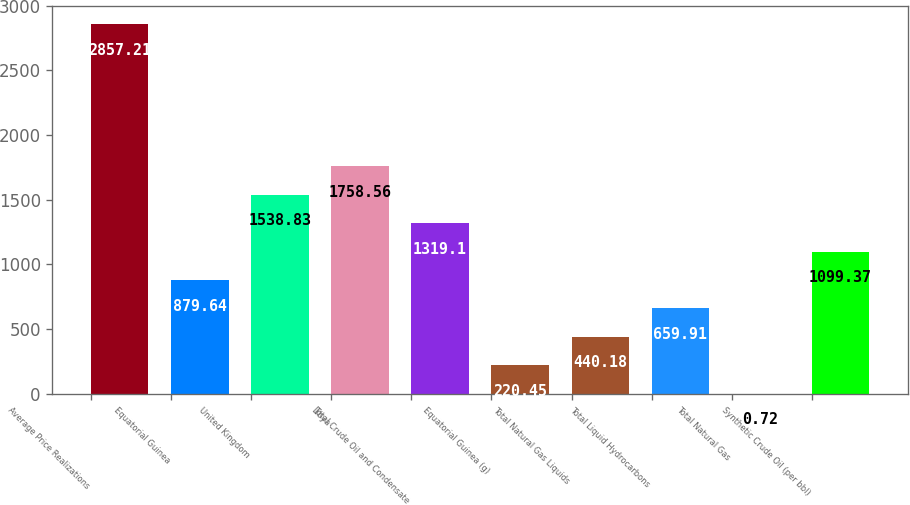Convert chart. <chart><loc_0><loc_0><loc_500><loc_500><bar_chart><fcel>Average Price Realizations<fcel>Equatorial Guinea<fcel>United Kingdom<fcel>Libya<fcel>Total Crude Oil and Condensate<fcel>Equatorial Guinea (g)<fcel>Total Natural Gas Liquids<fcel>Total Liquid Hydrocarbons<fcel>Total Natural Gas<fcel>Synthetic Crude Oil (per bbl)<nl><fcel>2857.21<fcel>879.64<fcel>1538.83<fcel>1758.56<fcel>1319.1<fcel>220.45<fcel>440.18<fcel>659.91<fcel>0.72<fcel>1099.37<nl></chart> 